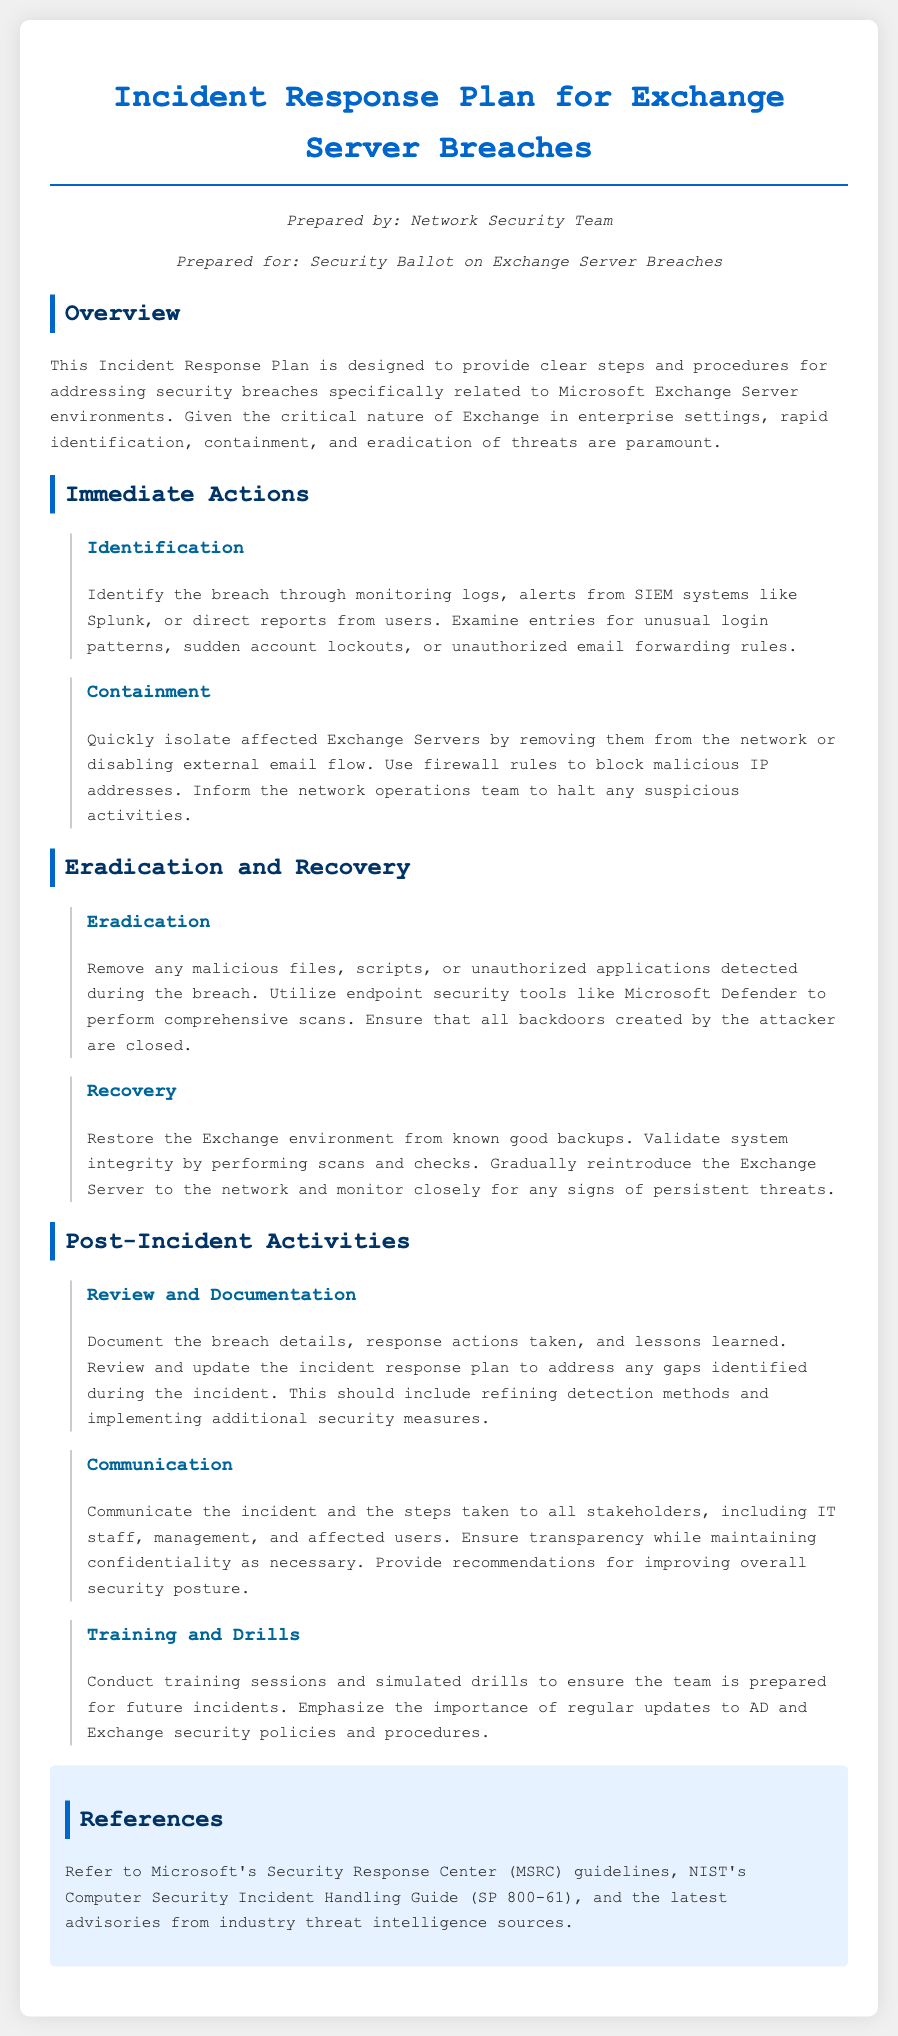What is the title of the document? The title of the document is specified in the header section, indicating its subject matter.
Answer: Incident Response Plan for Exchange Server Breaches Who prepared the document? The document states who prepared it in the prepared info section.
Answer: Network Security Team What should be the first immediate action during a breach? The document outlines the steps for responding to a breach, starting with the identification process.
Answer: Identification Which tool is recommended for comprehensive scans during eradication? The document specifies a tool to be utilized for scans after a breach in the eradication section.
Answer: Microsoft Defender What are the two main components of the recovery phase? The document elaborates on actions necessary for recovery following eradication, listing key steps involved.
Answer: Restore from backups and validate system integrity What type of training should be conducted post-incident? The document suggests the type of training that should follow an incident to enhance preparedness.
Answer: Conduct training sessions and simulated drills What is the purpose of communicating the incident to stakeholders? The document clarifies the significance of communication after a breach event.
Answer: Ensure transparency while maintaining confidentiality Which guidelines are recommended for reference in the document? The document provides a list of references to consult concerning security incidents.
Answer: Microsoft’s Security Response Center (MSRC) guidelines 